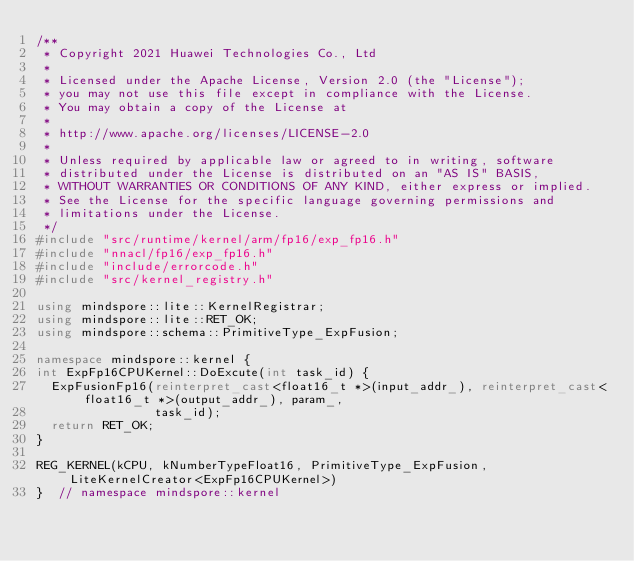<code> <loc_0><loc_0><loc_500><loc_500><_C++_>/**
 * Copyright 2021 Huawei Technologies Co., Ltd
 *
 * Licensed under the Apache License, Version 2.0 (the "License");
 * you may not use this file except in compliance with the License.
 * You may obtain a copy of the License at
 *
 * http://www.apache.org/licenses/LICENSE-2.0
 *
 * Unless required by applicable law or agreed to in writing, software
 * distributed under the License is distributed on an "AS IS" BASIS,
 * WITHOUT WARRANTIES OR CONDITIONS OF ANY KIND, either express or implied.
 * See the License for the specific language governing permissions and
 * limitations under the License.
 */
#include "src/runtime/kernel/arm/fp16/exp_fp16.h"
#include "nnacl/fp16/exp_fp16.h"
#include "include/errorcode.h"
#include "src/kernel_registry.h"

using mindspore::lite::KernelRegistrar;
using mindspore::lite::RET_OK;
using mindspore::schema::PrimitiveType_ExpFusion;

namespace mindspore::kernel {
int ExpFp16CPUKernel::DoExcute(int task_id) {
  ExpFusionFp16(reinterpret_cast<float16_t *>(input_addr_), reinterpret_cast<float16_t *>(output_addr_), param_,
                task_id);
  return RET_OK;
}

REG_KERNEL(kCPU, kNumberTypeFloat16, PrimitiveType_ExpFusion, LiteKernelCreator<ExpFp16CPUKernel>)
}  // namespace mindspore::kernel
</code> 